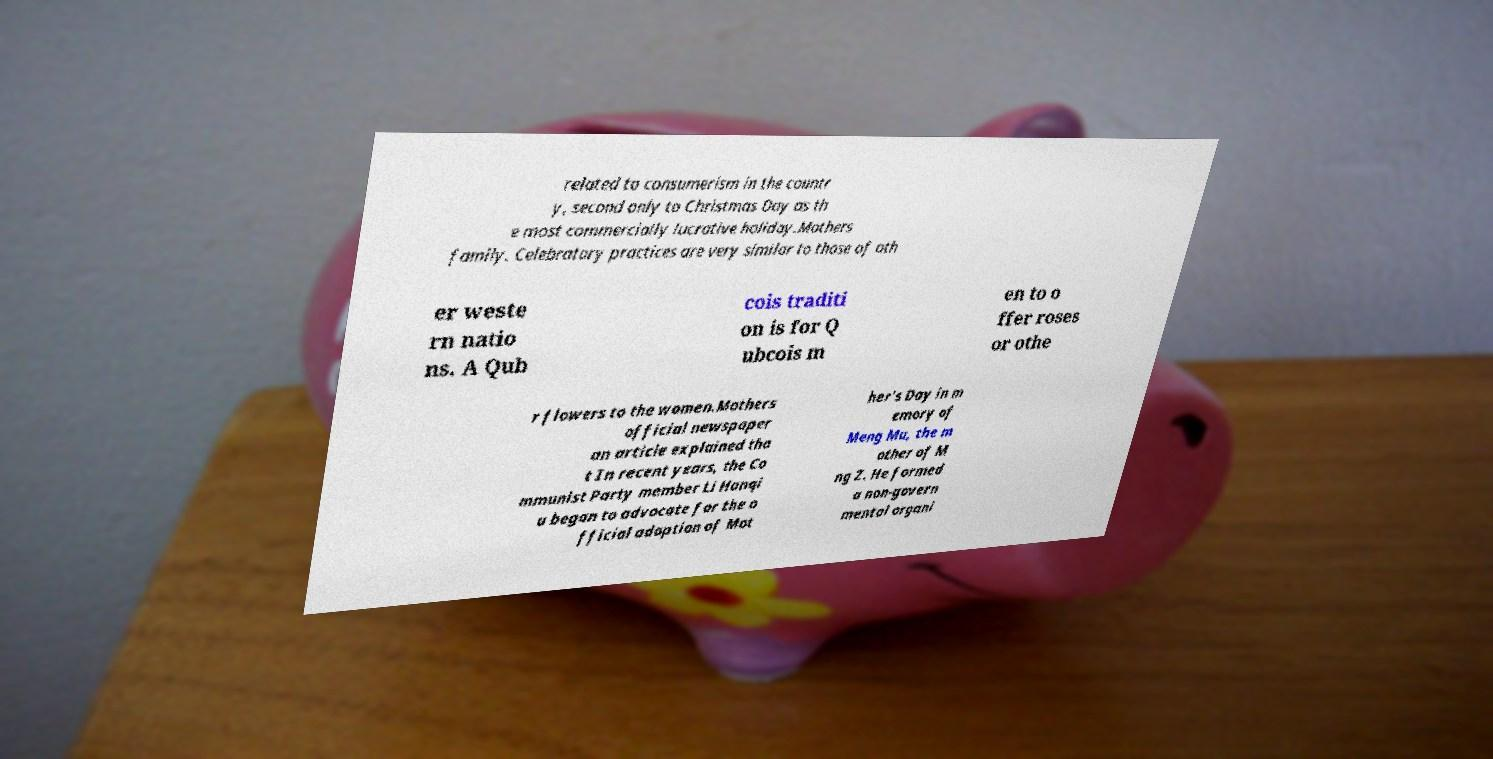I need the written content from this picture converted into text. Can you do that? related to consumerism in the countr y, second only to Christmas Day as th e most commercially lucrative holiday.Mothers family. Celebratory practices are very similar to those of oth er weste rn natio ns. A Qub cois traditi on is for Q ubcois m en to o ffer roses or othe r flowers to the women.Mothers official newspaper an article explained tha t In recent years, the Co mmunist Party member Li Hanqi u began to advocate for the o fficial adoption of Mot her's Day in m emory of Meng Mu, the m other of M ng Z. He formed a non-govern mental organi 